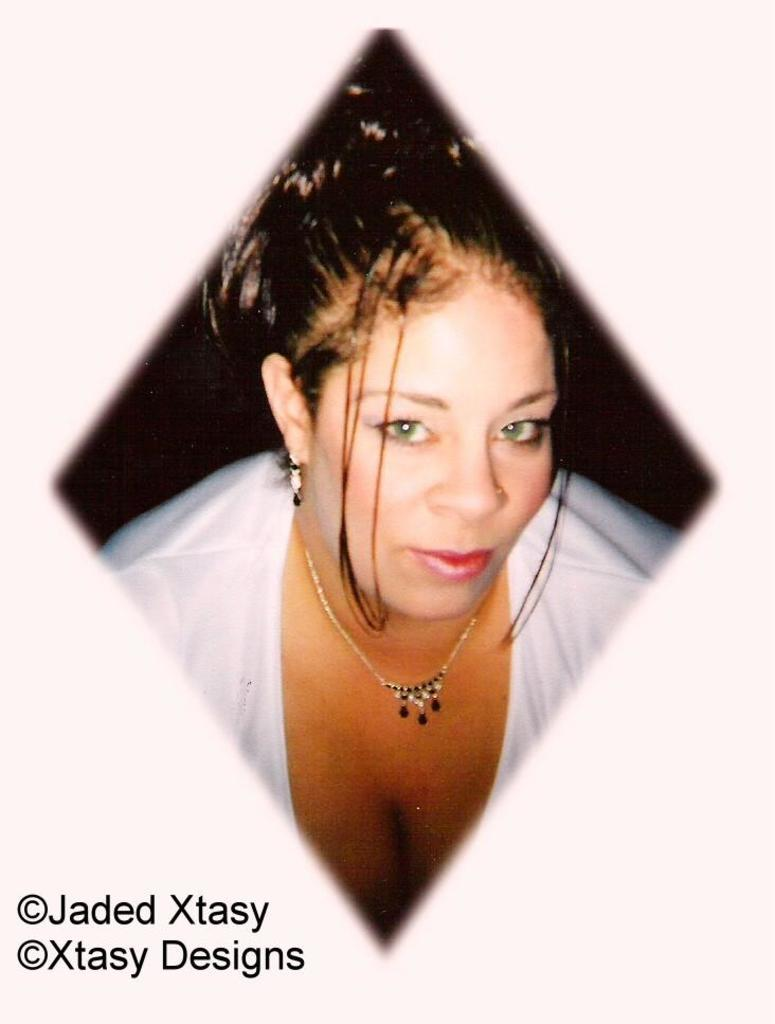Who is the main subject in the image? There is a lady in the image. What accessories is the lady wearing? The lady is wearing a necklace and earrings. What is the color of the background in the image? The background of the image is white. Is there any additional marking or feature in the image? Yes, there is a watermark in the left corner of the image. What type of yarn is the lady using to teach in the image? There is no yarn or teaching activity present in the image. What year is depicted in the image? The image does not depict a specific year. 